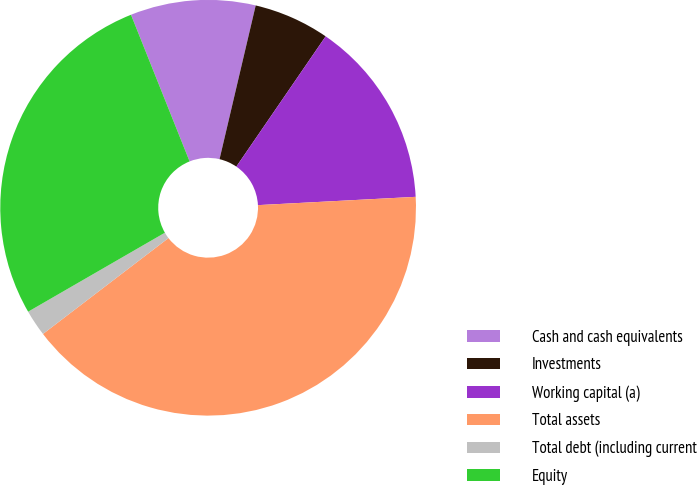<chart> <loc_0><loc_0><loc_500><loc_500><pie_chart><fcel>Cash and cash equivalents<fcel>Investments<fcel>Working capital (a)<fcel>Total assets<fcel>Total debt (including current<fcel>Equity<nl><fcel>9.73%<fcel>5.89%<fcel>14.6%<fcel>40.46%<fcel>2.05%<fcel>27.29%<nl></chart> 